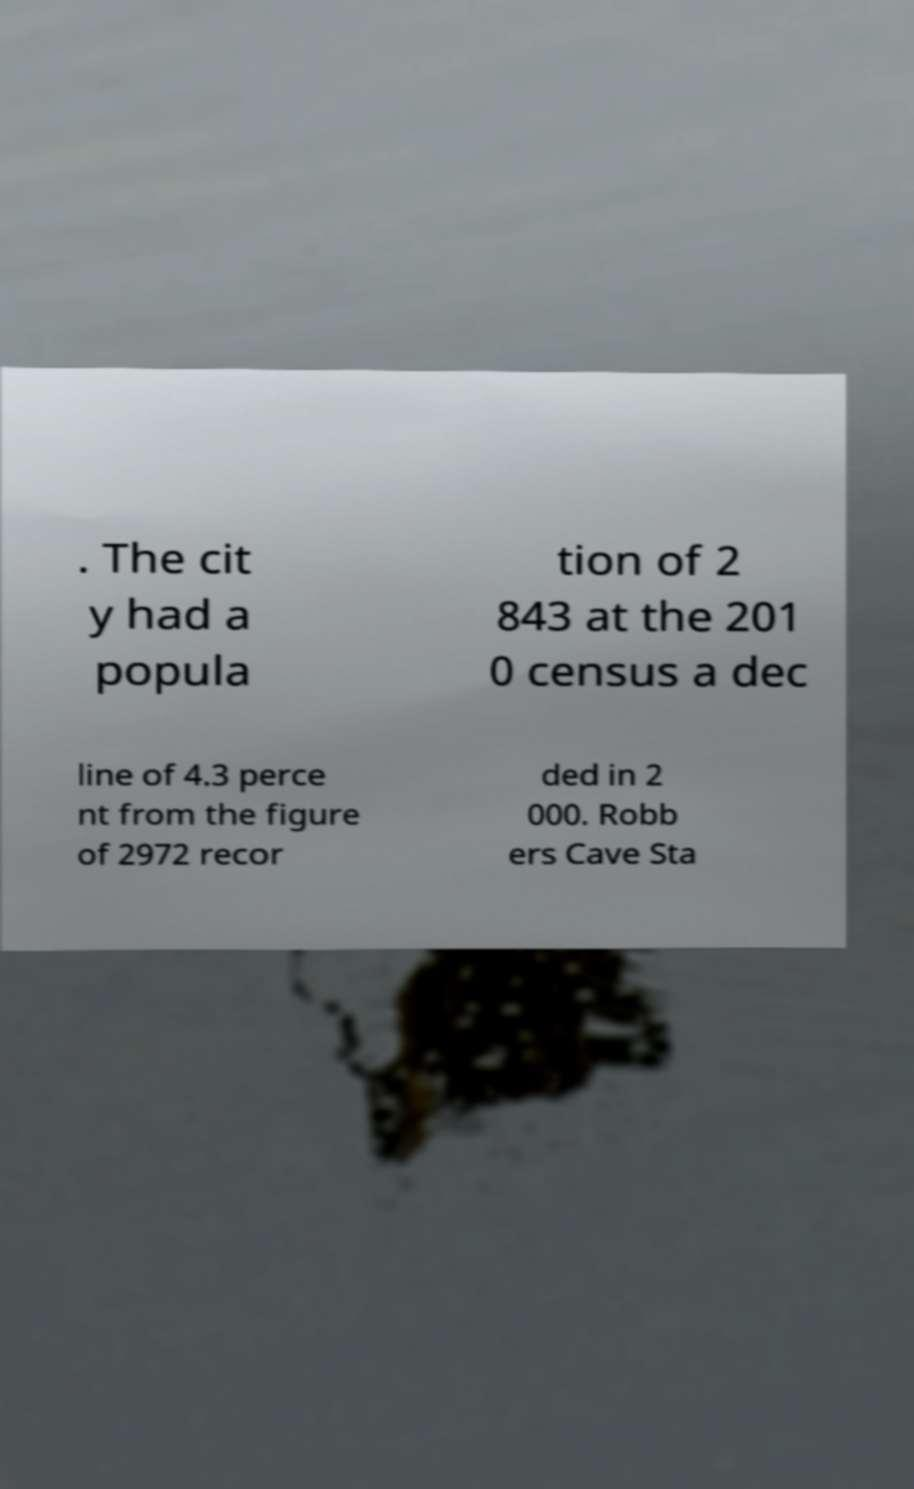Can you accurately transcribe the text from the provided image for me? . The cit y had a popula tion of 2 843 at the 201 0 census a dec line of 4.3 perce nt from the figure of 2972 recor ded in 2 000. Robb ers Cave Sta 